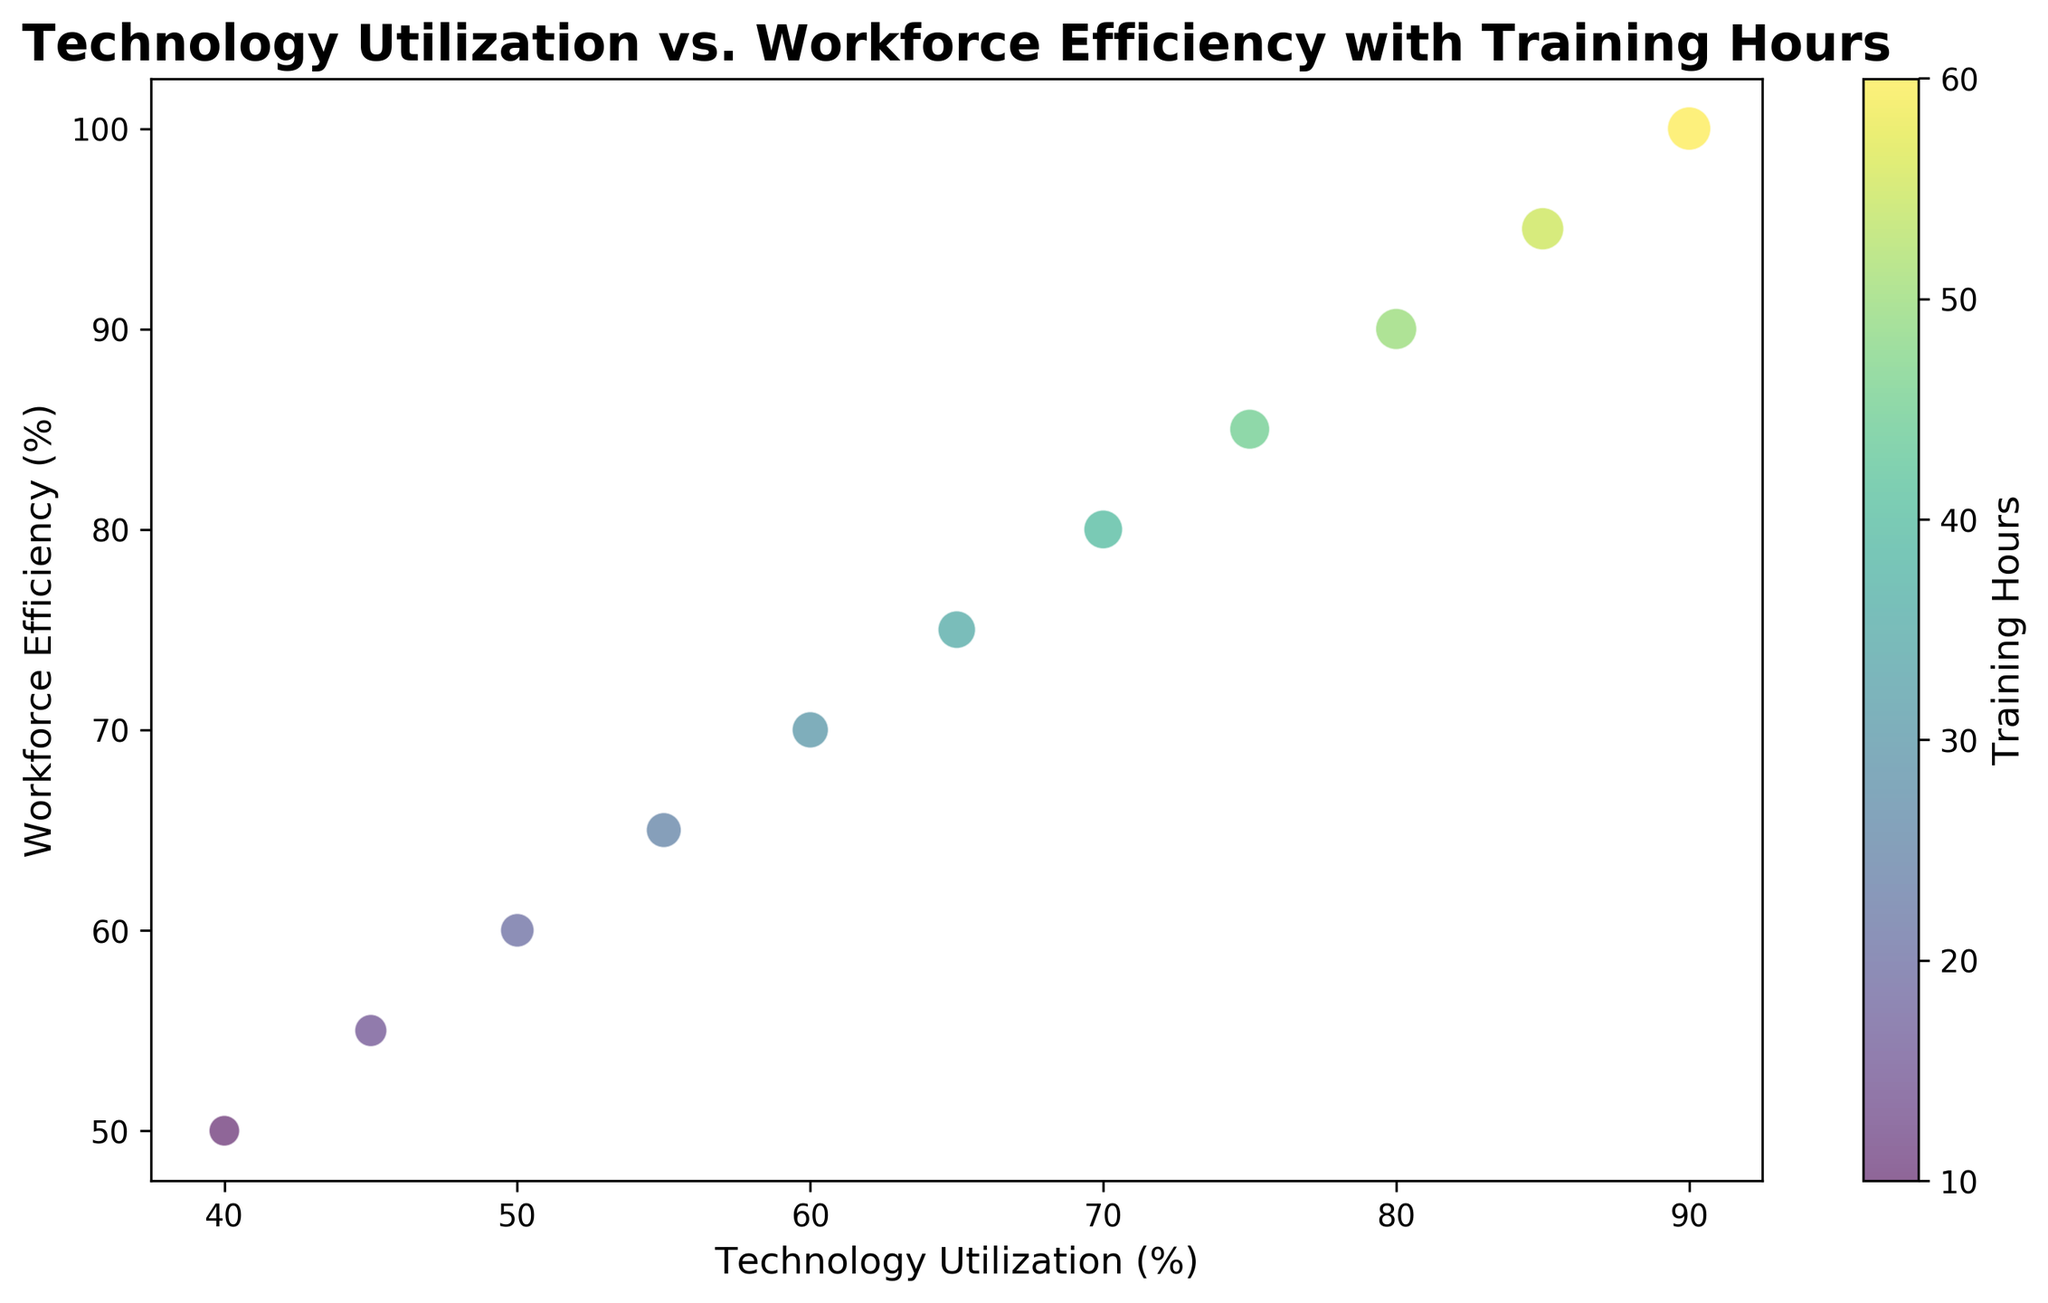What is the maximum workforce efficiency observed in the chart? To find the maximum workforce efficiency, look at the highest point on the Workforce Efficiency axis. The highest value is 100%, located at the top of the chart.
Answer: 100% Which bubble represents the highest technology utilization, and what is its corresponding workforce efficiency? The bubble furthest to the right on the Technology Utilization axis represents the highest technology utilization, which is 90%. Its corresponding workforce efficiency is the y-value at this position, which is 100%.
Answer: 90%, 100% How many bubbles indicate a technology utilization of more than 70%? Count the number of bubbles with their x-values (Technology Utilization) greater than 70%. There are four bubbles with Technology Utilization values of 75%, 80%, 85%, and 90%.
Answer: 4 What is the average workforce efficiency for technology utilization values of 50%, 60%, and 70%? Identify the workforce efficiency for Technology Utilization values of 50% (60%), 60% (70%), and 70% (80%). Add these values (60 + 70 + 80 = 210) and then divide by 3 to find the average (210/3 = 70).
Answer: 70% Which bubble is colored the lightest and what is its training hours? The lightest colored bubble corresponds to the highest training hours in the viridis color map. The bubble with the highest training hours (60) at Tech Utilization 90% and Workforce Efficiency 100% is the lightest.
Answer: 60 Does Workforce Efficiency always increase with Technology Utilization in the chart? Observe the trend of the bubbles from left to right. Workforce Efficiency increases consistently with higher Technology Utilization throughout the chart, showing a positive trend without any irregularities.
Answer: Yes Which bubble has the largest size, and what does this correspond to in terms of training hours? The largest bubble is the one with the biggest circumference, corresponding to a Bubble Size of 200, which represents 60 Training Hours at 90% Tech Utilization and 100% Workforce Efficiency.
Answer: Training Hours: 60 Compare the workforce efficiency for Technology Utilization of 40% and 70%. Which is higher and by how much? Identify the Workforce Efficiency at 40% (50%) and at 70% (80%). The difference is calculated as 80% - 50% = 30%.
Answer: 70% by 30% Which Technology Utilization levels have the same Workforce Efficiency increase step from their previous level? Calculate the increases in Workforce Efficiency moving from each Technology Utilization level. All increments are consistent (e.g., 50% to 55%, 55% to 60%, etc.) except the initial step which is different. Each subsequent step consistently increases by 5%.
Answer: All consistent steps have 5% increase What is the total sum of Bubble Sizes for Technology Utilization levels less than 60%? Sum the sizes of bubbles at Tech Utilization: 40% (100), 45% (110), 50% (120), 55% (130). Total = 100 + 110 + 120 + 130 = 460.
Answer: 460 